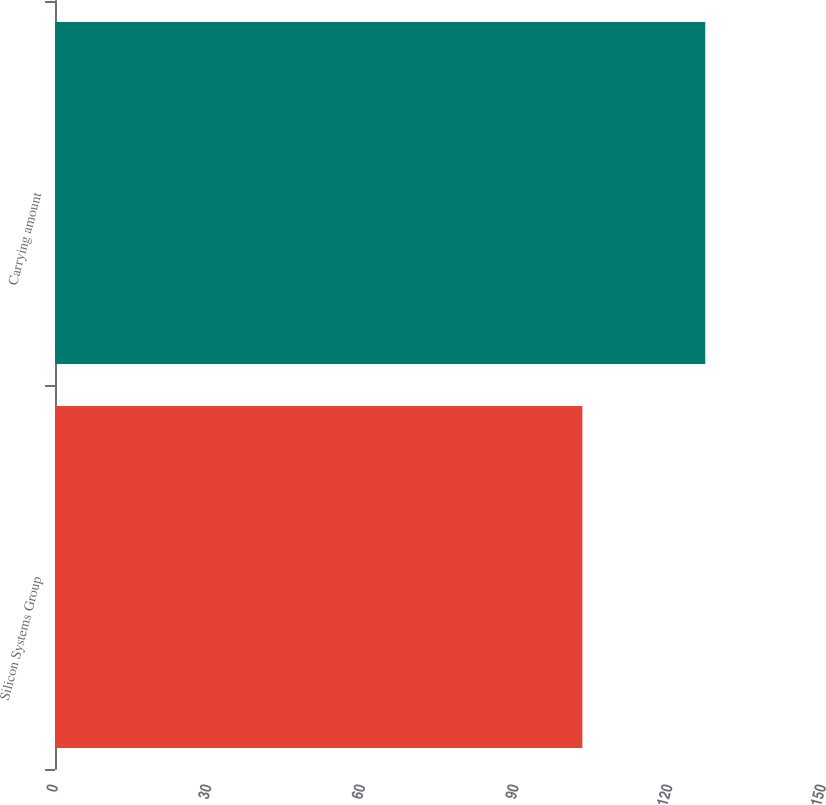<chart> <loc_0><loc_0><loc_500><loc_500><bar_chart><fcel>Silicon Systems Group<fcel>Carrying amount<nl><fcel>103<fcel>127<nl></chart> 